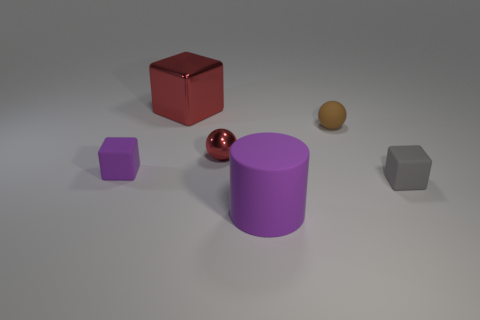There is a object that is the same color as the tiny shiny ball; what is it made of?
Ensure brevity in your answer.  Metal. What shape is the brown rubber thing?
Provide a short and direct response. Sphere. Is the number of red blocks right of the big purple rubber cylinder the same as the number of small gray rubber blocks?
Provide a succinct answer. No. Is there anything else that is made of the same material as the red sphere?
Provide a short and direct response. Yes. Do the big red object left of the tiny red shiny object and the small brown sphere have the same material?
Give a very brief answer. No. Is the number of purple rubber blocks that are on the right side of the tiny gray cube less than the number of small gray matte objects?
Your answer should be very brief. Yes. How many metal things are either large things or gray blocks?
Your answer should be very brief. 1. Does the matte cylinder have the same color as the large metal object?
Offer a very short reply. No. Is there anything else that has the same color as the metal cube?
Your answer should be compact. Yes. Is the shape of the tiny rubber thing behind the purple matte cube the same as the red metal thing in front of the red block?
Ensure brevity in your answer.  Yes. 